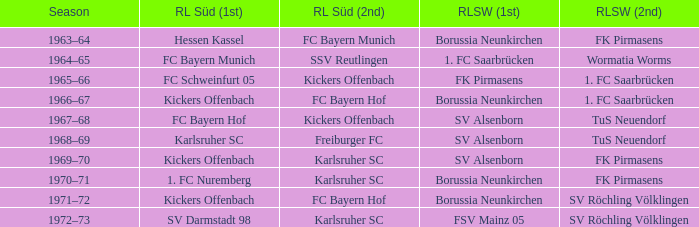What season did SV Darmstadt 98 end up at RL Süd (1st)? 1972–73. 